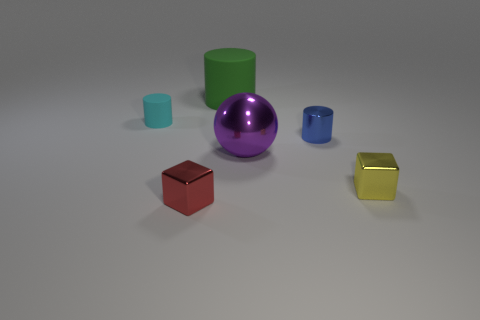There is a cyan object that is the same material as the large green object; what is its shape? cylinder 